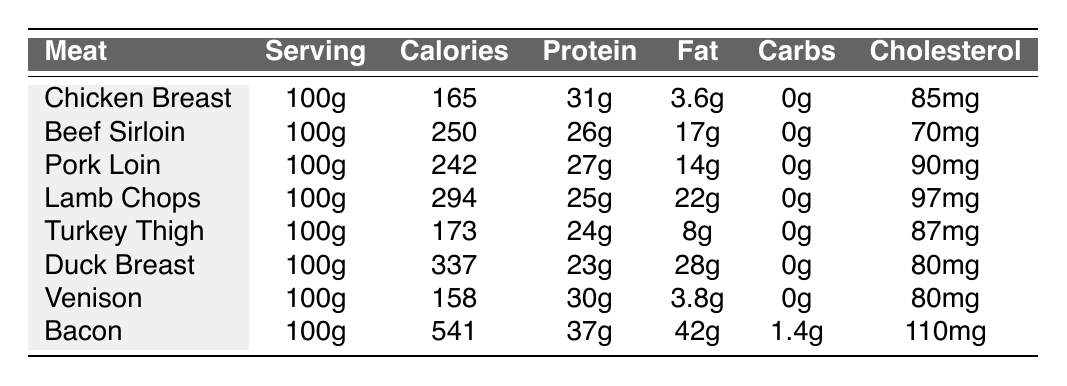What is the calorie content of Chicken Breast? The table shows that Chicken Breast has a calorie content of 165.
Answer: 165 Which meat contains the highest amount of protein? Referring to the table, Bacon has the highest protein content at 37g.
Answer: 37g What is the total fat content of both Pork Loin and Beef Sirloin combined? The fat content of Pork Loin is 14g, and for Beef Sirloin, it is 17g. Adding them together gives 14g + 17g = 31g.
Answer: 31g Does Duck Breast have more calories than Turkey Thigh? Duck Breast has 337 calories, while Turkey Thigh has 173 calories. Since 337 is greater than 173, the statement is true.
Answer: Yes What is the average cholesterol content of all the meats listed? The total cholesterol content is 85mg + 70mg + 90mg + 97mg + 87mg + 80mg + 80mg + 110mg = 719mg. Dividing this by 8 gives an average cholesterol content of 719mg / 8 = 89.875mg.
Answer: 89.88mg Which meat has the least amount of calories? By examining the table, Venison has the lowest calorie content at 158 calories.
Answer: 158 If you were to compare the fat content of Bacon and Duck Breast, how much more fat does Bacon have? Bacon has 42g of fat, and Duck Breast has 28g. Subtracting these gives 42g - 28g = 14g more fat in Bacon.
Answer: 14g Is there a meat listed that has zero carbohydrates? Looking at the table, all the meats listed have 0g in the carbohydrates column, making this statement true.
Answer: Yes 